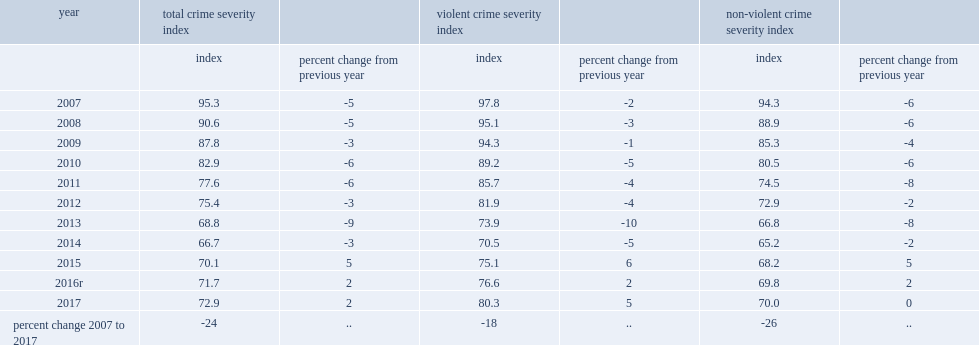What was the percent change from previous year in 2017? 2.0. 